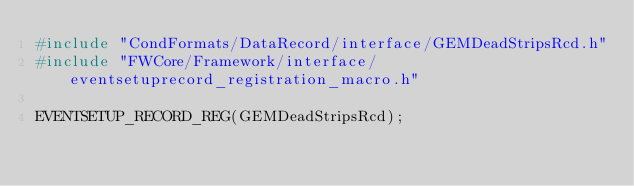Convert code to text. <code><loc_0><loc_0><loc_500><loc_500><_C++_>#include "CondFormats/DataRecord/interface/GEMDeadStripsRcd.h"
#include "FWCore/Framework/interface/eventsetuprecord_registration_macro.h"

EVENTSETUP_RECORD_REG(GEMDeadStripsRcd);
</code> 